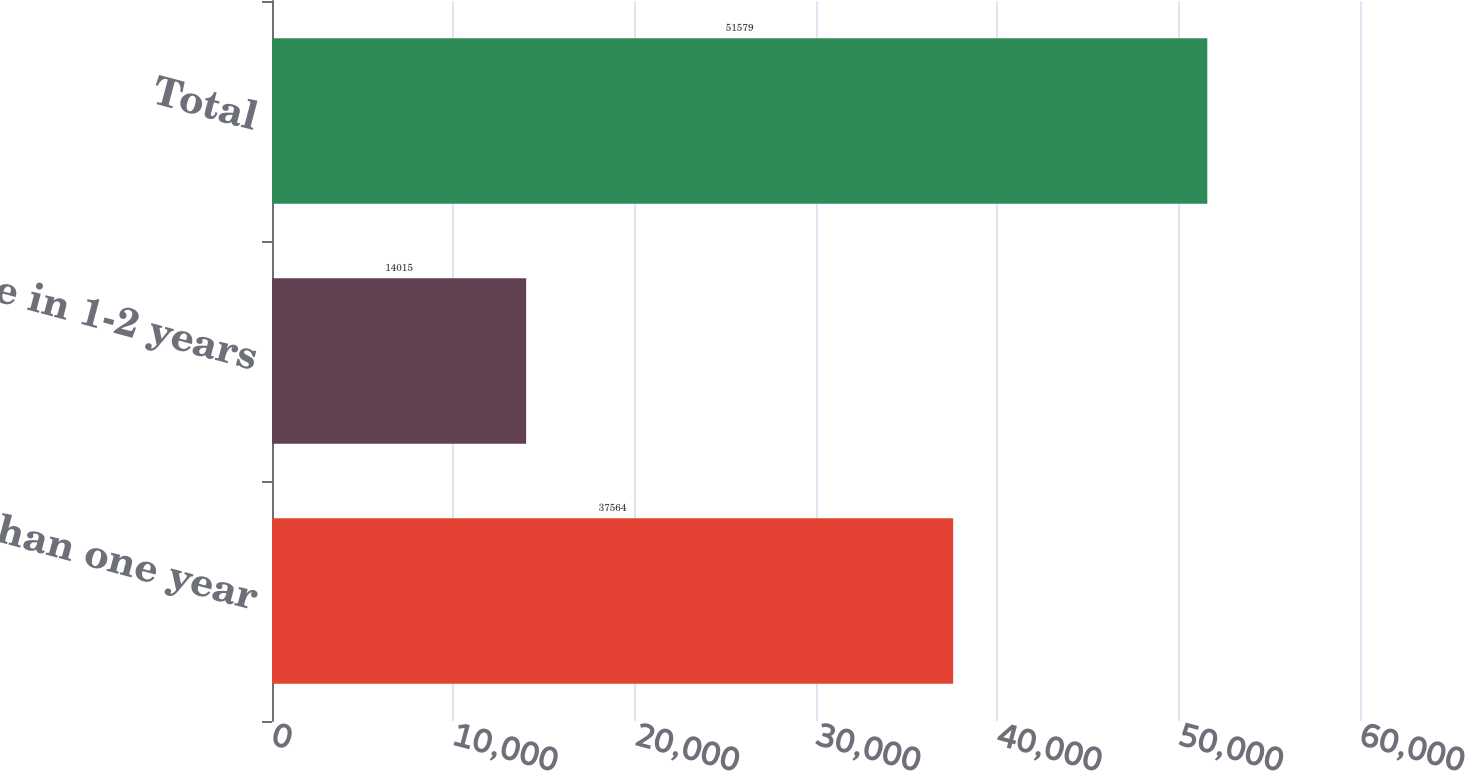<chart> <loc_0><loc_0><loc_500><loc_500><bar_chart><fcel>Less than one year<fcel>Due in 1-2 years<fcel>Total<nl><fcel>37564<fcel>14015<fcel>51579<nl></chart> 